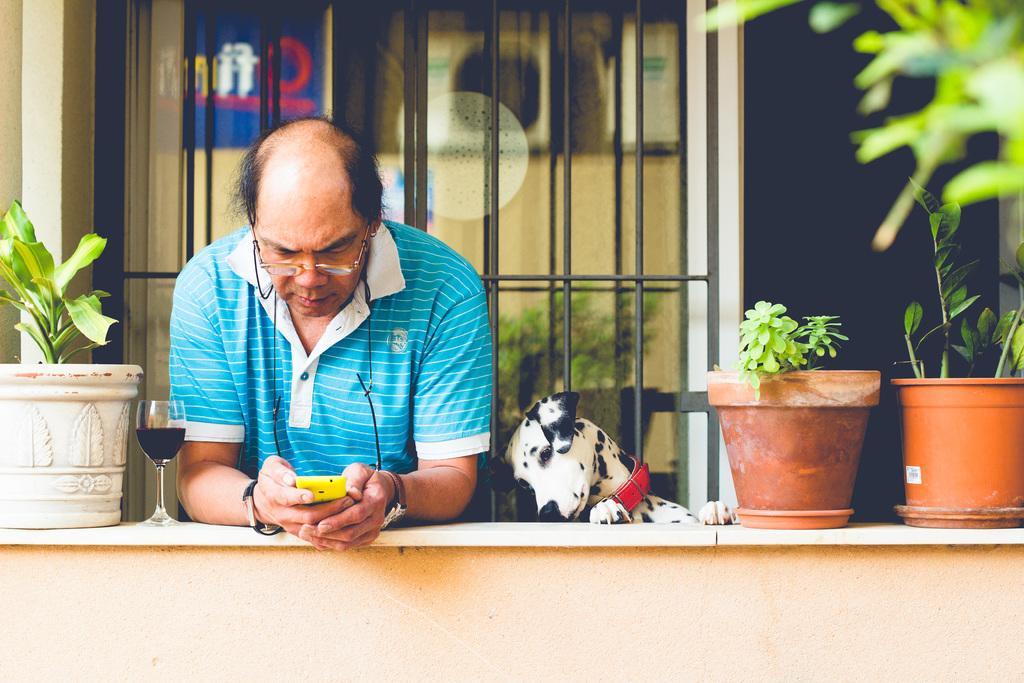Can you describe this image briefly? In this image a man wearing blue t-shirt is holding a phone. On the wall there are plant pot. A dog is standing beside the man. In the background there is window. 